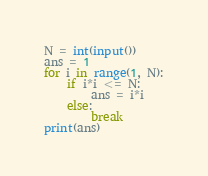<code> <loc_0><loc_0><loc_500><loc_500><_Python_>N = int(input())
ans = 1
for i in range(1, N):
    if i*i <= N:
        ans = i*i
    else:
        break
print(ans)</code> 